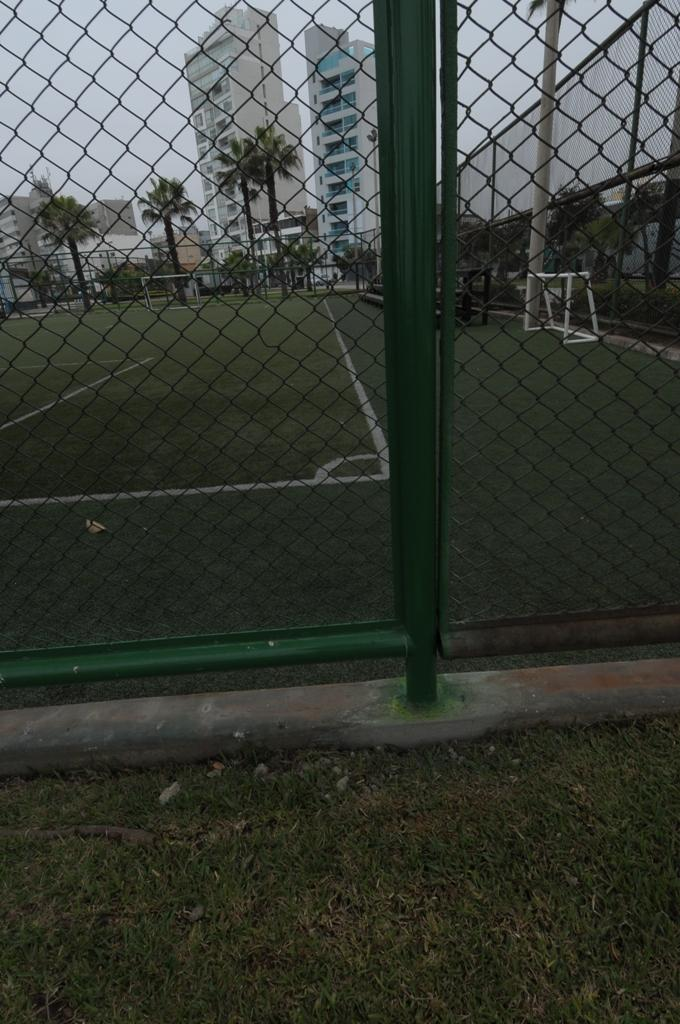What type of barrier is visible in the image? There is a green fence in the image. What is located in front of the fence? There is a greenery ground in front of the fence. What can be seen in the background of the image? There are trees and buildings in the background of the image. What type of trail can be seen running through the park in the image? There is no park or trail present in the image; it features a green fence, greenery ground, trees, and buildings in the background. 